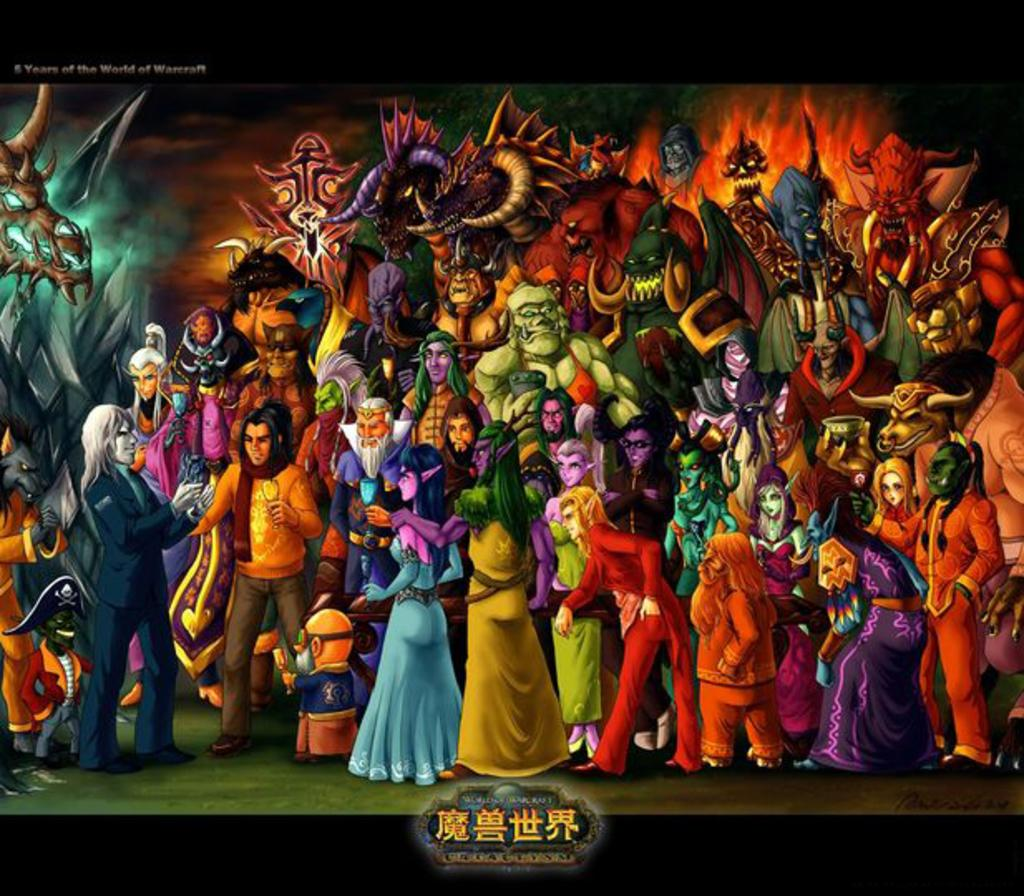What type of visual might the image be? The image might be a poster. Can you describe the people in the image? There are people in the image, and they are wearing costumes. Is there any text present in the image? Yes, there is text at the bottom of the image. What type of cracker is being used to make observations in the image? There is no cracker present in the image, and no observations are being made. 